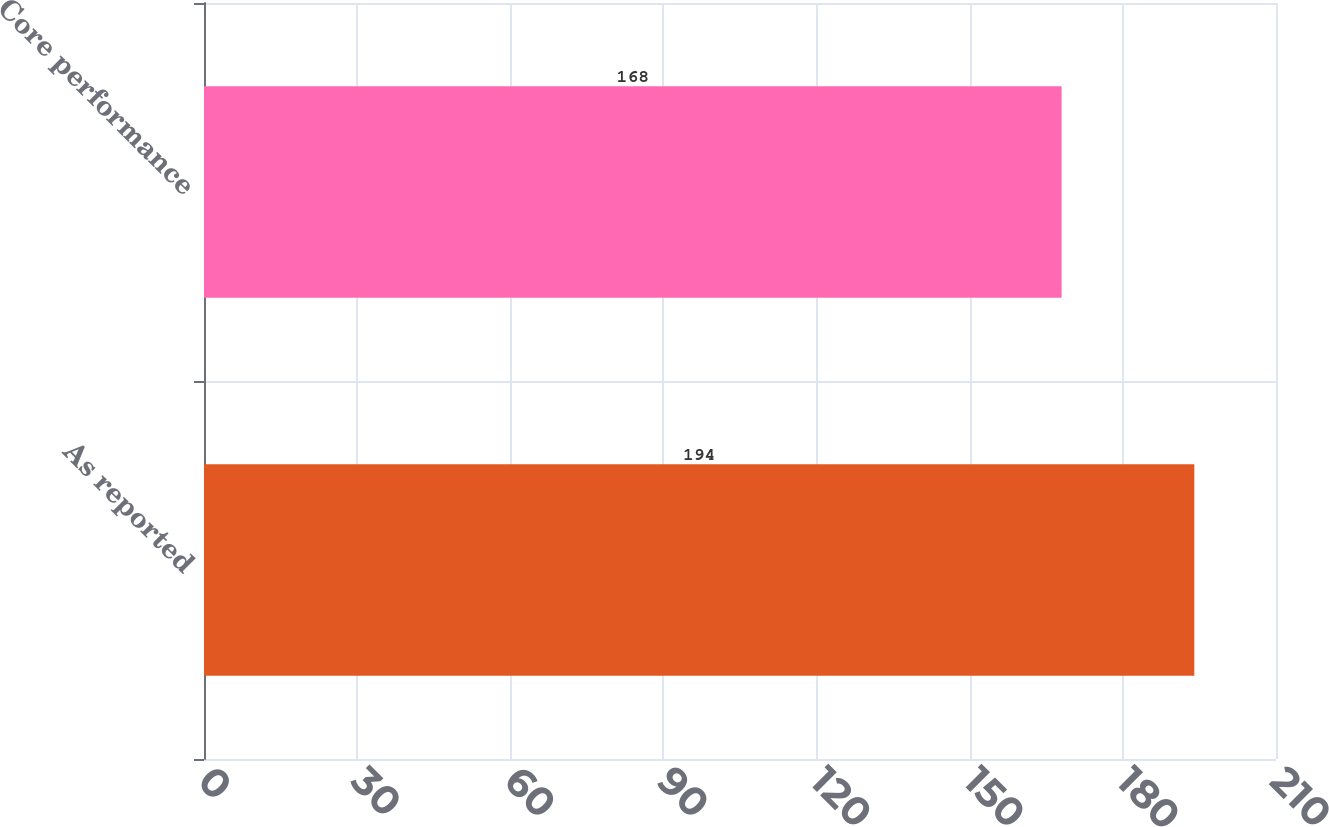Convert chart to OTSL. <chart><loc_0><loc_0><loc_500><loc_500><bar_chart><fcel>As reported<fcel>Core performance<nl><fcel>194<fcel>168<nl></chart> 